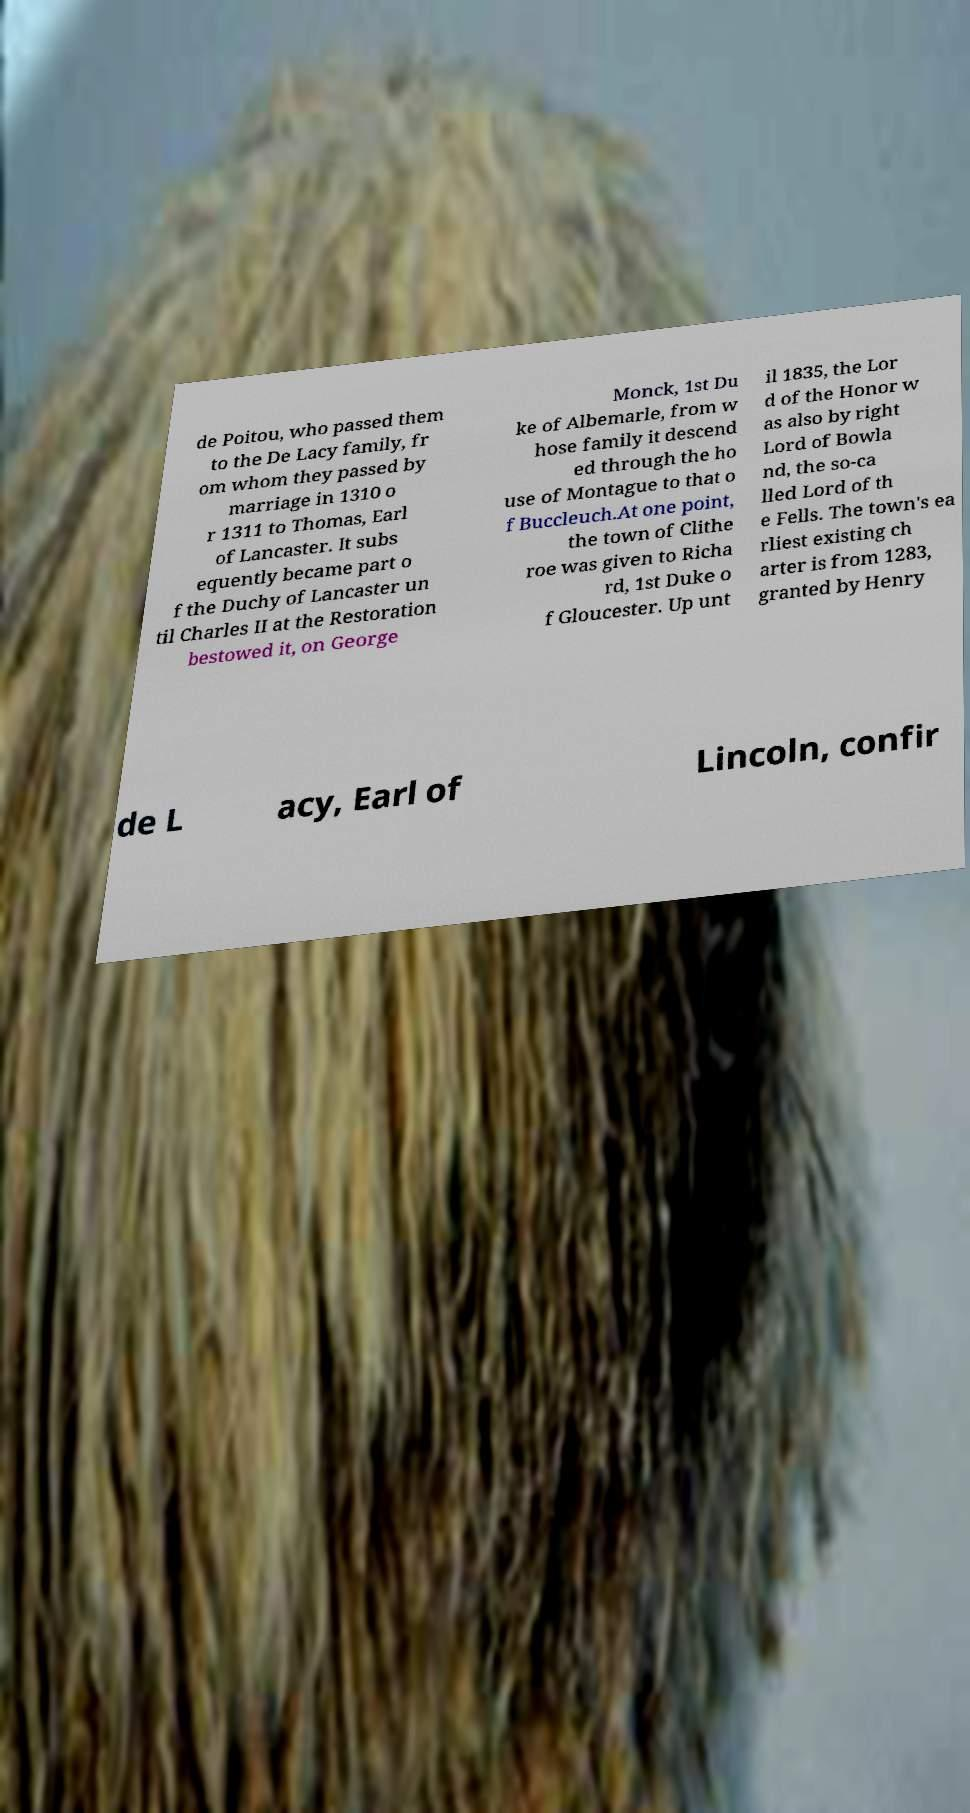I need the written content from this picture converted into text. Can you do that? de Poitou, who passed them to the De Lacy family, fr om whom they passed by marriage in 1310 o r 1311 to Thomas, Earl of Lancaster. It subs equently became part o f the Duchy of Lancaster un til Charles II at the Restoration bestowed it, on George Monck, 1st Du ke of Albemarle, from w hose family it descend ed through the ho use of Montague to that o f Buccleuch.At one point, the town of Clithe roe was given to Richa rd, 1st Duke o f Gloucester. Up unt il 1835, the Lor d of the Honor w as also by right Lord of Bowla nd, the so-ca lled Lord of th e Fells. The town's ea rliest existing ch arter is from 1283, granted by Henry de L acy, Earl of Lincoln, confir 